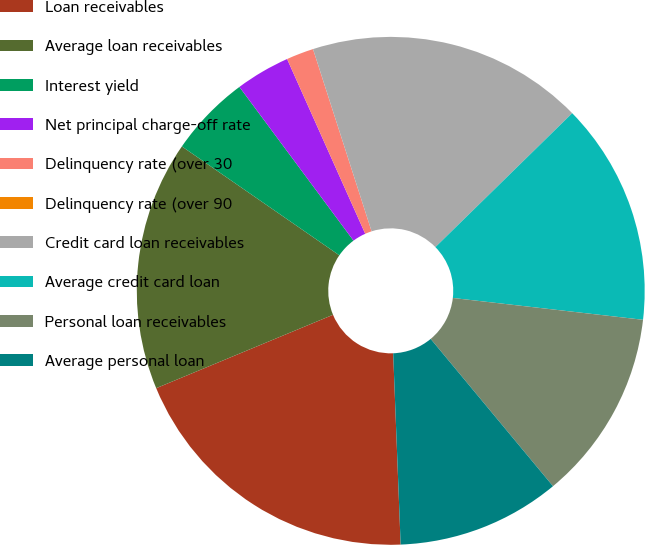<chart> <loc_0><loc_0><loc_500><loc_500><pie_chart><fcel>Loan receivables<fcel>Average loan receivables<fcel>Interest yield<fcel>Net principal charge-off rate<fcel>Delinquency rate (over 30<fcel>Delinquency rate (over 90<fcel>Credit card loan receivables<fcel>Average credit card loan<fcel>Personal loan receivables<fcel>Average personal loan<nl><fcel>19.36%<fcel>15.89%<fcel>5.21%<fcel>3.47%<fcel>1.74%<fcel>0.0%<fcel>17.62%<fcel>14.15%<fcel>12.15%<fcel>10.41%<nl></chart> 